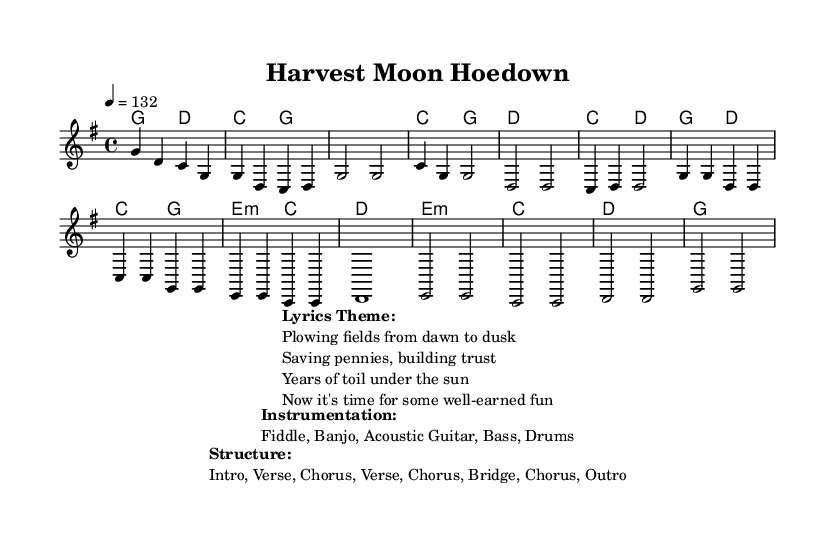What is the key signature of this music? The key signature is G major, which has one sharp (F#).
Answer: G major What is the time signature of the music? The time signature is indicated as 4/4, which means there are four beats per measure.
Answer: 4/4 What is the tempo marking for this piece? The tempo marking is indicated as "4 = 132," which means there are 132 quarter note beats per minute.
Answer: 132 How many verses are in the structure of the music? The structure indicates two verses, as listed before the choruses in the song's layout.
Answer: 2 What themes are present in the lyrics? The lyrics express themes of hard work and perseverance related to farming and enjoying the rewards of that labor.
Answer: Hard work, perseverance What instruments are featured in this dance music? The music specifies that the instrumentation includes fiddle, banjo, acoustic guitar, bass, and drums.
Answer: Fiddle, Banjo, Acoustic Guitar, Bass, Drums In which section does the bridge occur in this piece? The bridge is indicated to occur after the second verse and before the final chorus, suggesting a change in texture and theme during that part of the song.
Answer: Bridge 